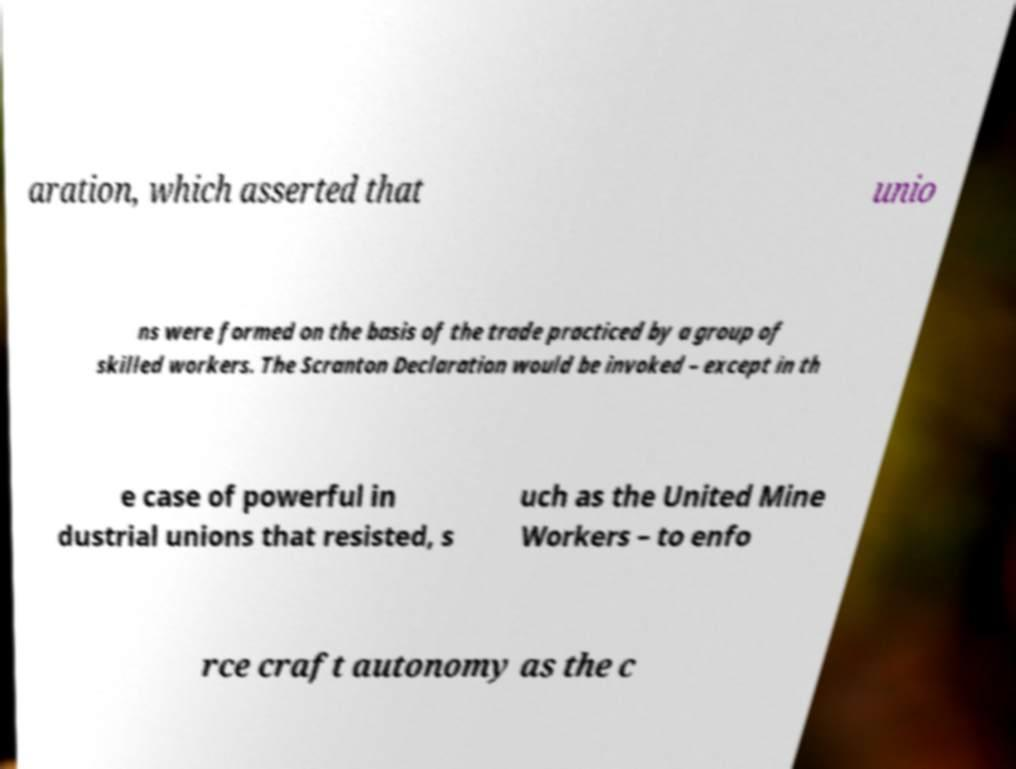Can you accurately transcribe the text from the provided image for me? aration, which asserted that unio ns were formed on the basis of the trade practiced by a group of skilled workers. The Scranton Declaration would be invoked – except in th e case of powerful in dustrial unions that resisted, s uch as the United Mine Workers – to enfo rce craft autonomy as the c 